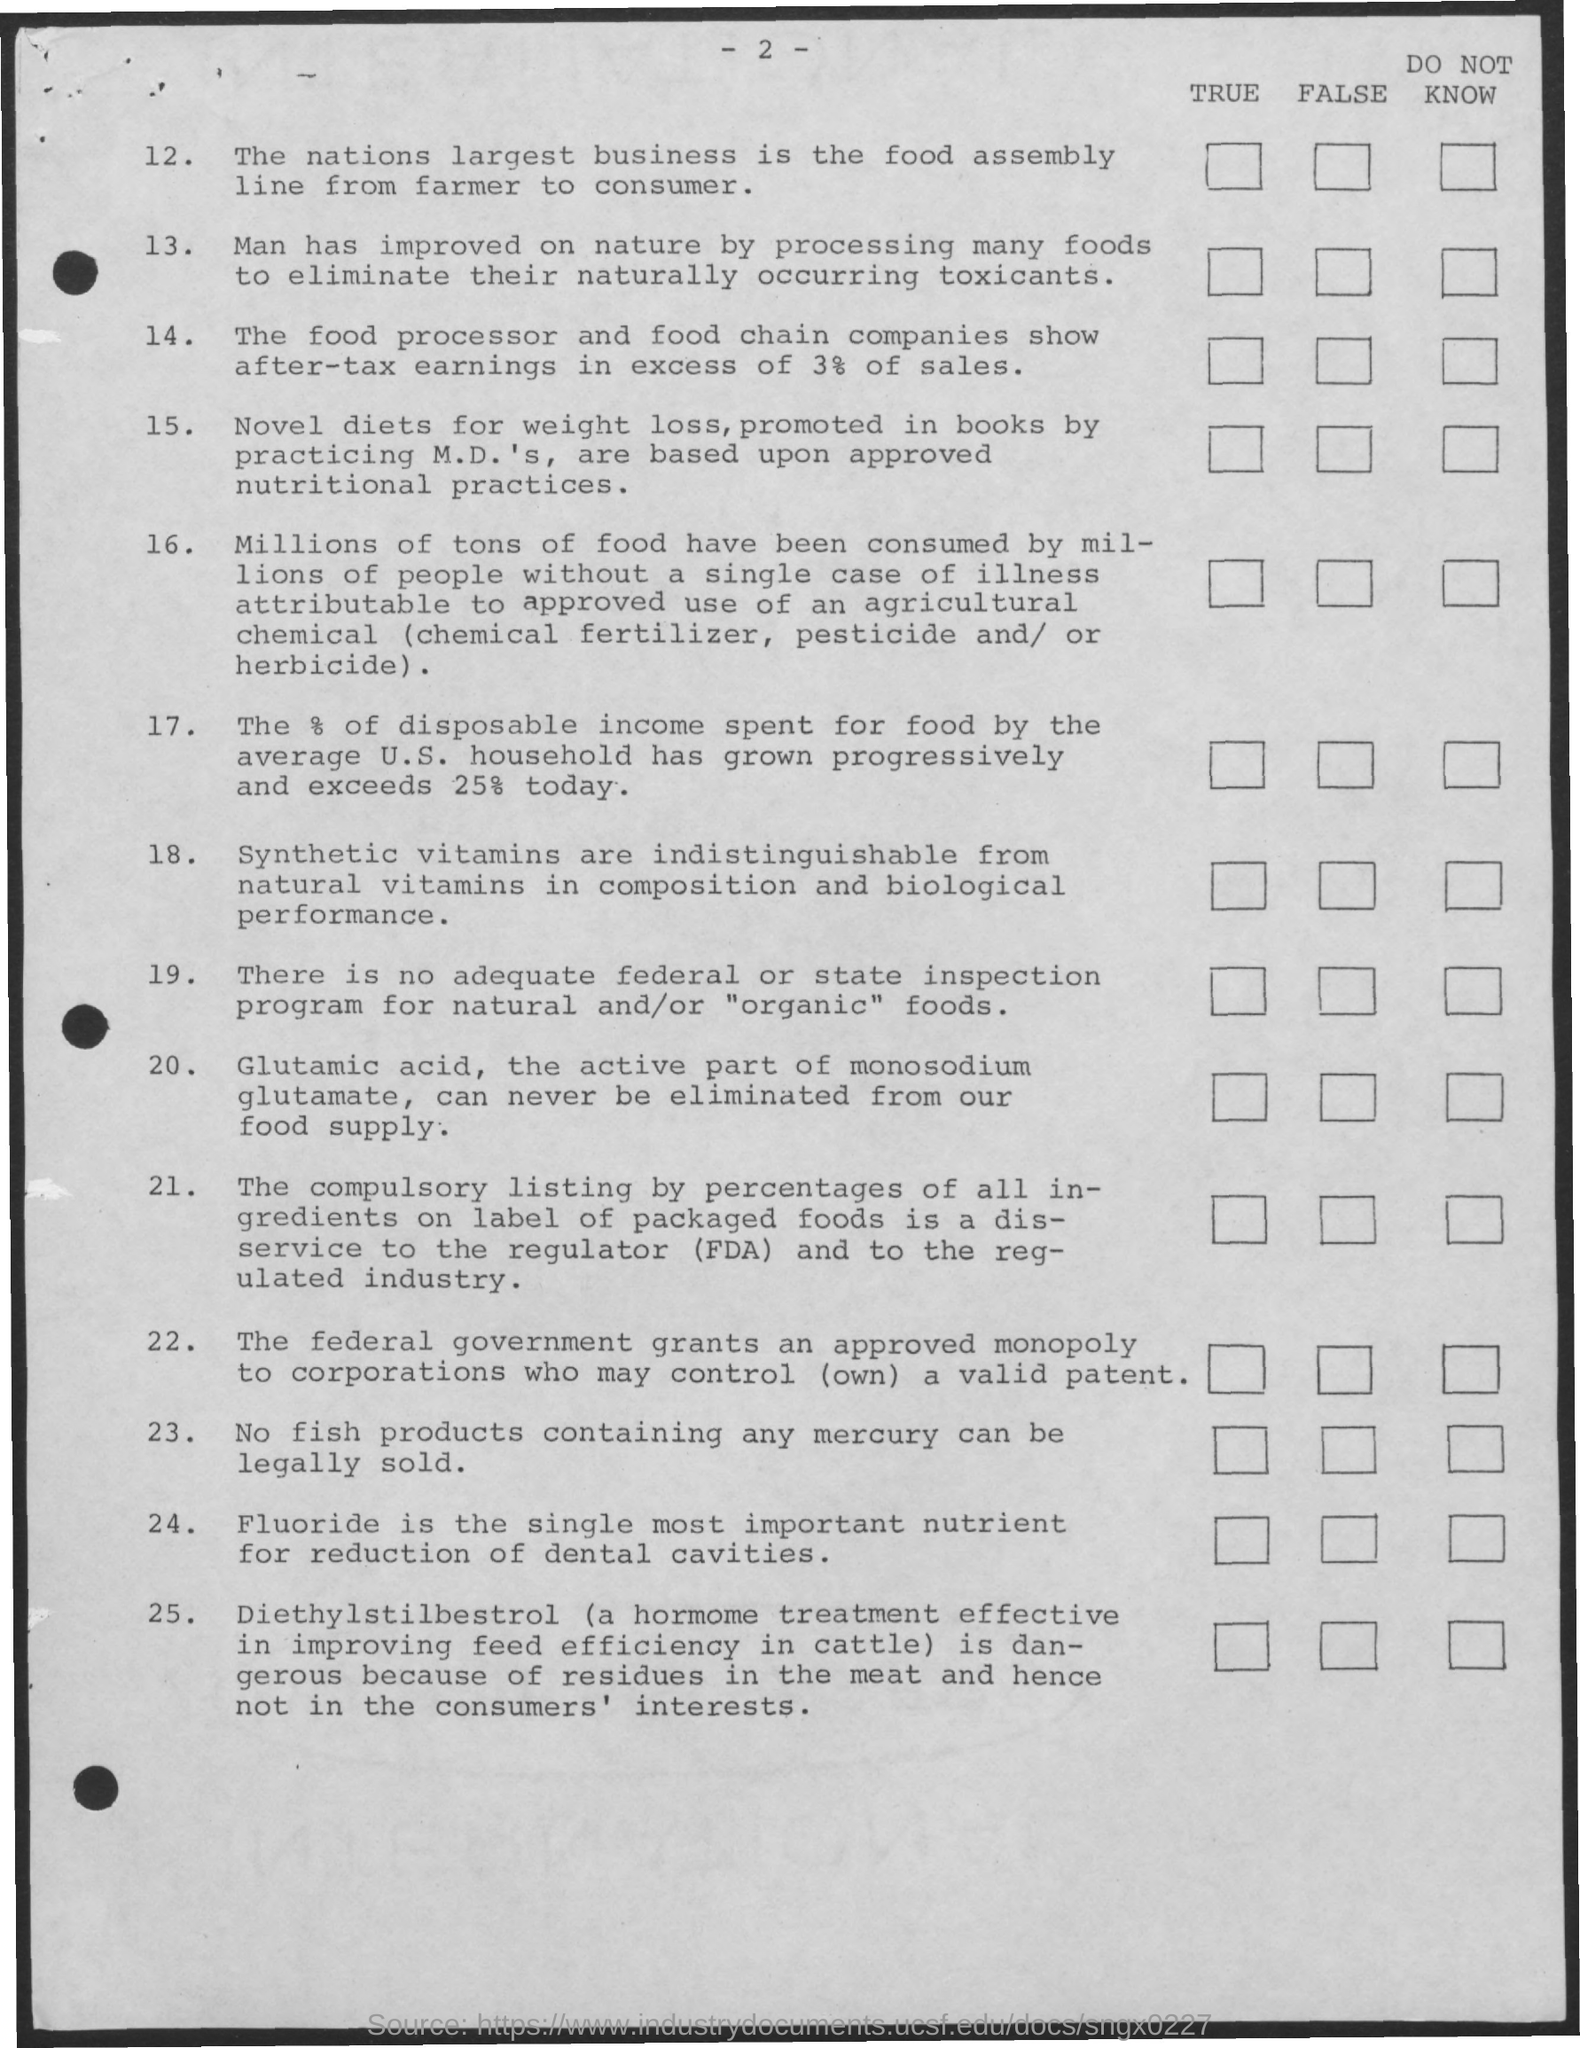Point out several critical features in this image. I am seeking the page number 2.. 